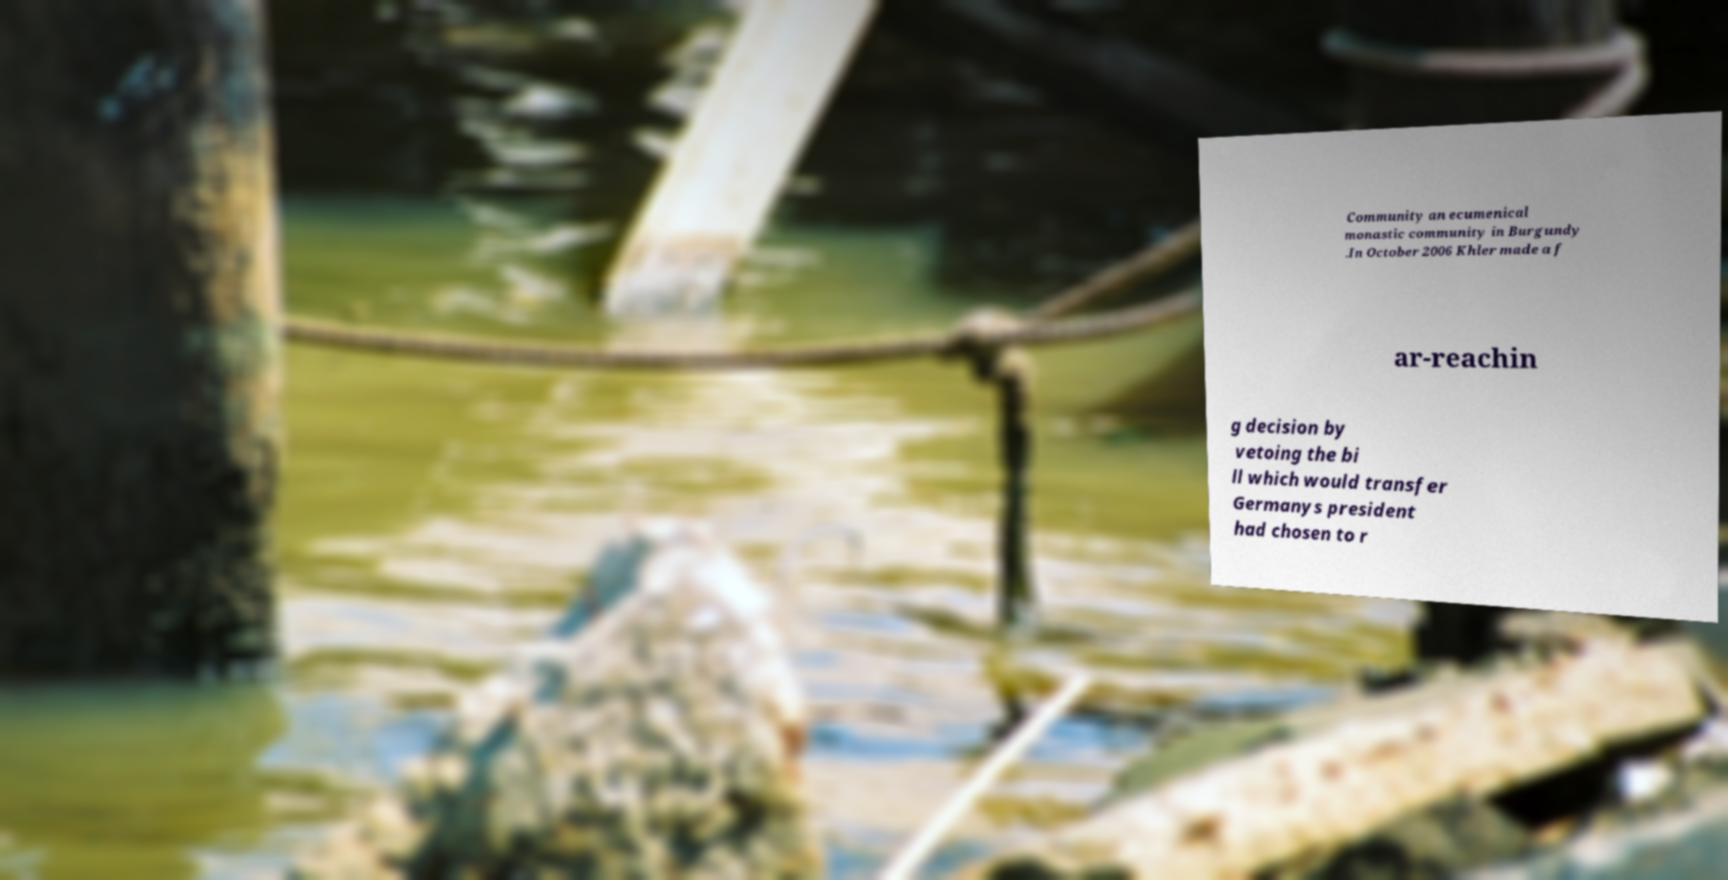I need the written content from this picture converted into text. Can you do that? Community an ecumenical monastic community in Burgundy .In October 2006 Khler made a f ar-reachin g decision by vetoing the bi ll which would transfer Germanys president had chosen to r 